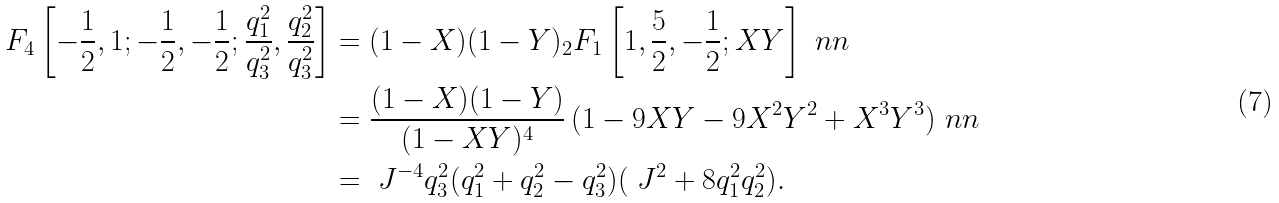<formula> <loc_0><loc_0><loc_500><loc_500>F _ { 4 } \left [ - \frac { 1 } { 2 } , 1 ; - \frac { 1 } { 2 } , - \frac { 1 } { 2 } ; \frac { q _ { 1 } ^ { 2 } } { q _ { 3 } ^ { 2 } } , \frac { q _ { 2 } ^ { 2 } } { q _ { 3 } ^ { 2 } } \right ] & = ( 1 - X ) ( 1 - Y ) _ { 2 } F _ { 1 } \left [ 1 , \frac { 5 } { 2 } , - \frac { 1 } { 2 } ; X Y \right ] \ n n \\ & = \frac { ( 1 - X ) ( 1 - Y ) } { ( 1 - X Y ) ^ { 4 } } \, ( 1 - 9 X Y - 9 X ^ { 2 } Y ^ { 2 } + X ^ { 3 } Y ^ { 3 } ) \ n n \\ & = \ J ^ { - 4 } q _ { 3 } ^ { 2 } ( q _ { 1 } ^ { 2 } + q _ { 2 } ^ { 2 } - q _ { 3 } ^ { 2 } ) ( \ J ^ { 2 } + 8 q _ { 1 } ^ { 2 } q _ { 2 } ^ { 2 } ) .</formula> 